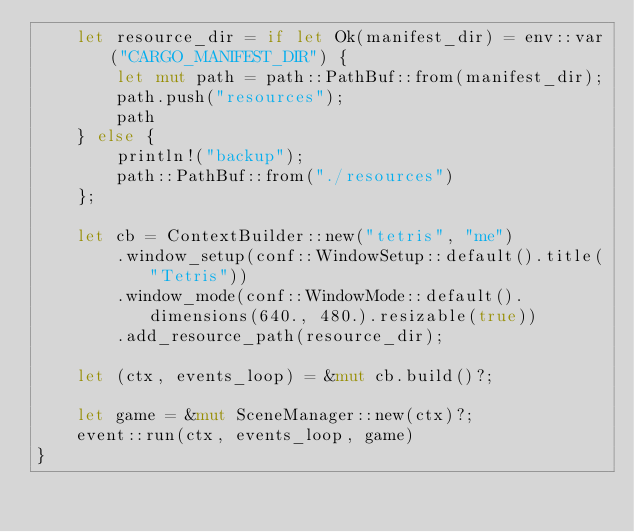Convert code to text. <code><loc_0><loc_0><loc_500><loc_500><_Rust_>    let resource_dir = if let Ok(manifest_dir) = env::var("CARGO_MANIFEST_DIR") {
        let mut path = path::PathBuf::from(manifest_dir);
        path.push("resources");
        path
    } else {
        println!("backup");
        path::PathBuf::from("./resources")
    };

    let cb = ContextBuilder::new("tetris", "me")
        .window_setup(conf::WindowSetup::default().title("Tetris"))
        .window_mode(conf::WindowMode::default().dimensions(640., 480.).resizable(true))
        .add_resource_path(resource_dir);

    let (ctx, events_loop) = &mut cb.build()?;

    let game = &mut SceneManager::new(ctx)?;
    event::run(ctx, events_loop, game)
}
</code> 